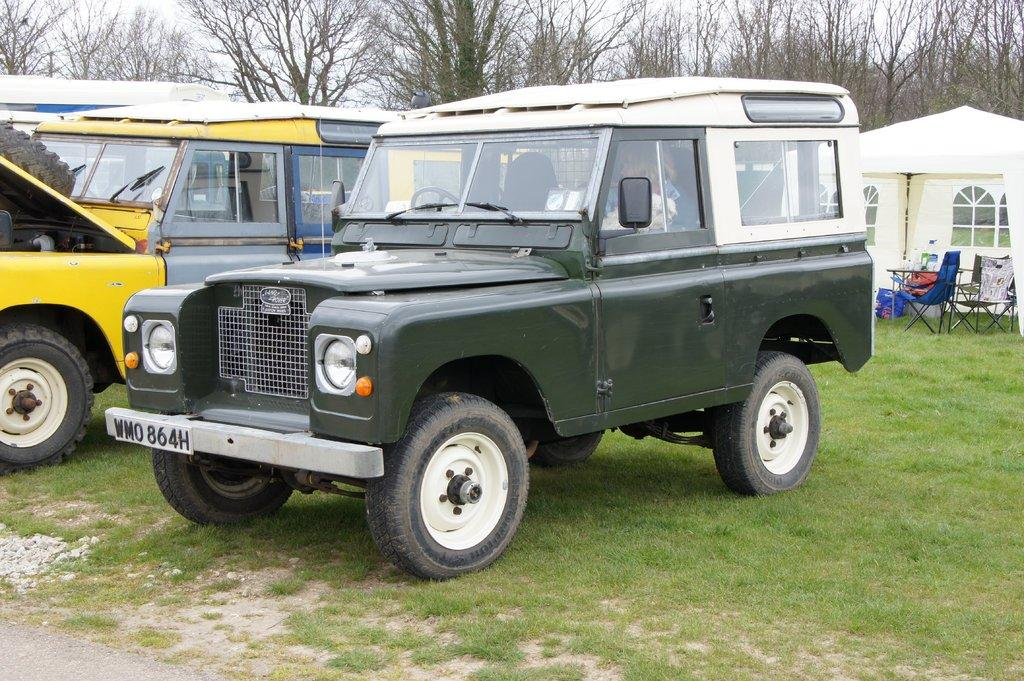How many jeeps are present in the image? There are two jeeps in the image. Where are the jeeps located? The jeeps are parked on the grass. What other objects can be seen in the image? There are chairs and a table in the image. What type of shelter is visible in the image? There is a tent in the image. What can be seen behind the tent? Trees are visible behind the tent. What is the distance between the two jeeps in the image? The distance between the two jeeps cannot be determined from the image alone, as there is no reference point to measure the distance. 